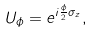Convert formula to latex. <formula><loc_0><loc_0><loc_500><loc_500>U _ { \phi } = e ^ { i \frac { \phi } { 2 } \sigma _ { z } } ,</formula> 